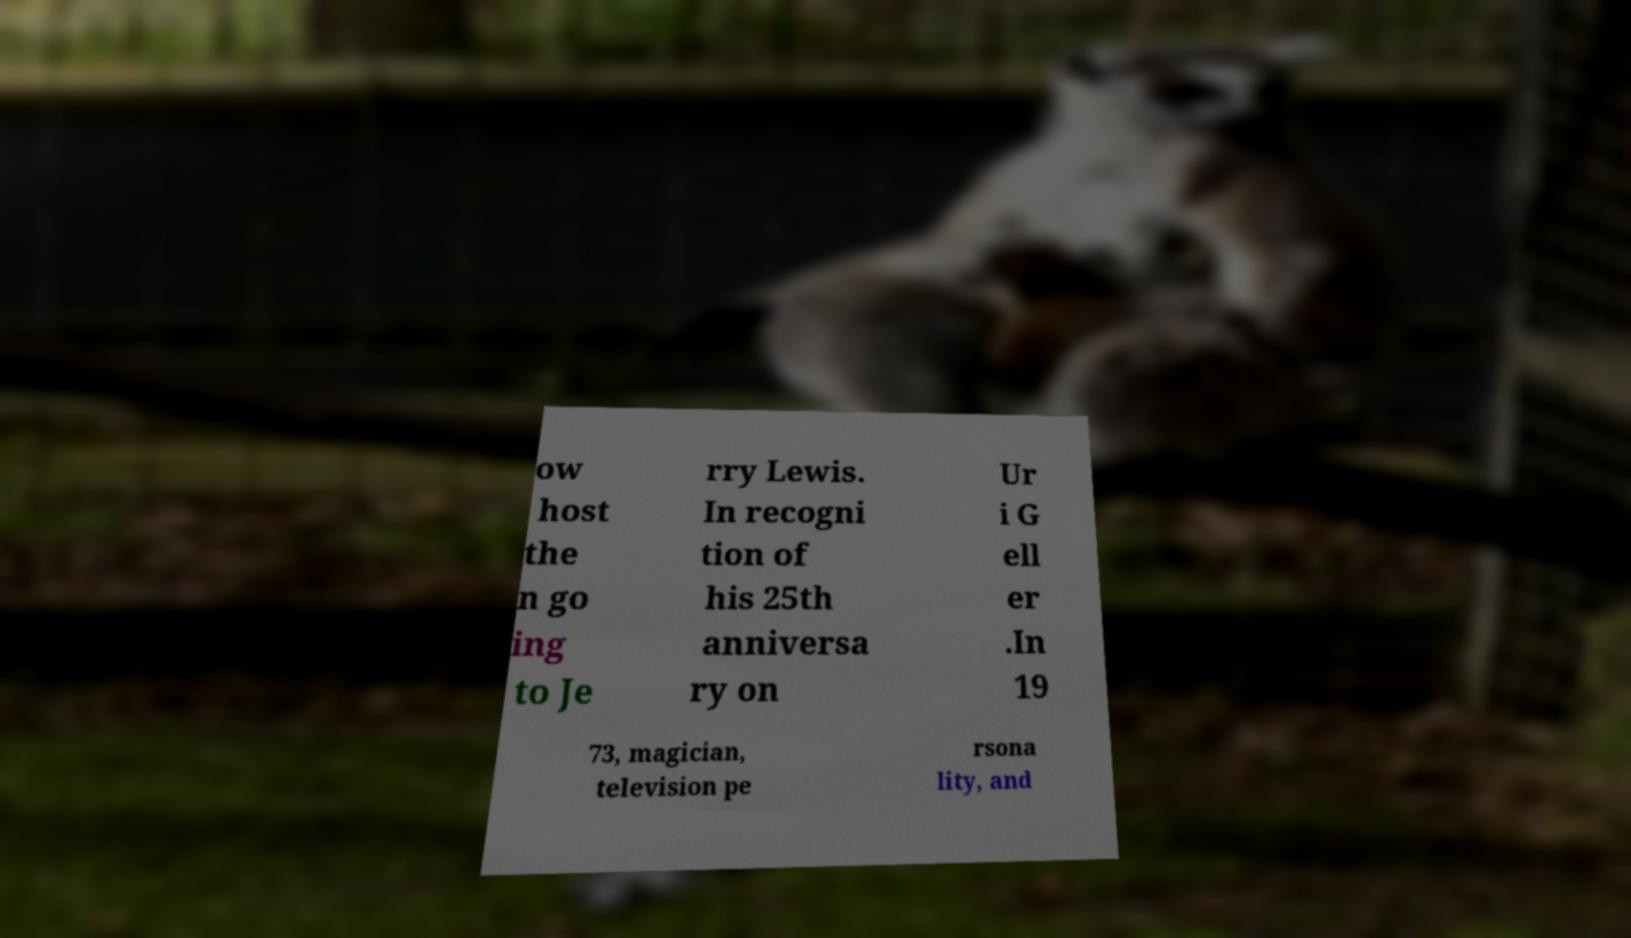Can you accurately transcribe the text from the provided image for me? ow host the n go ing to Je rry Lewis. In recogni tion of his 25th anniversa ry on Ur i G ell er .In 19 73, magician, television pe rsona lity, and 